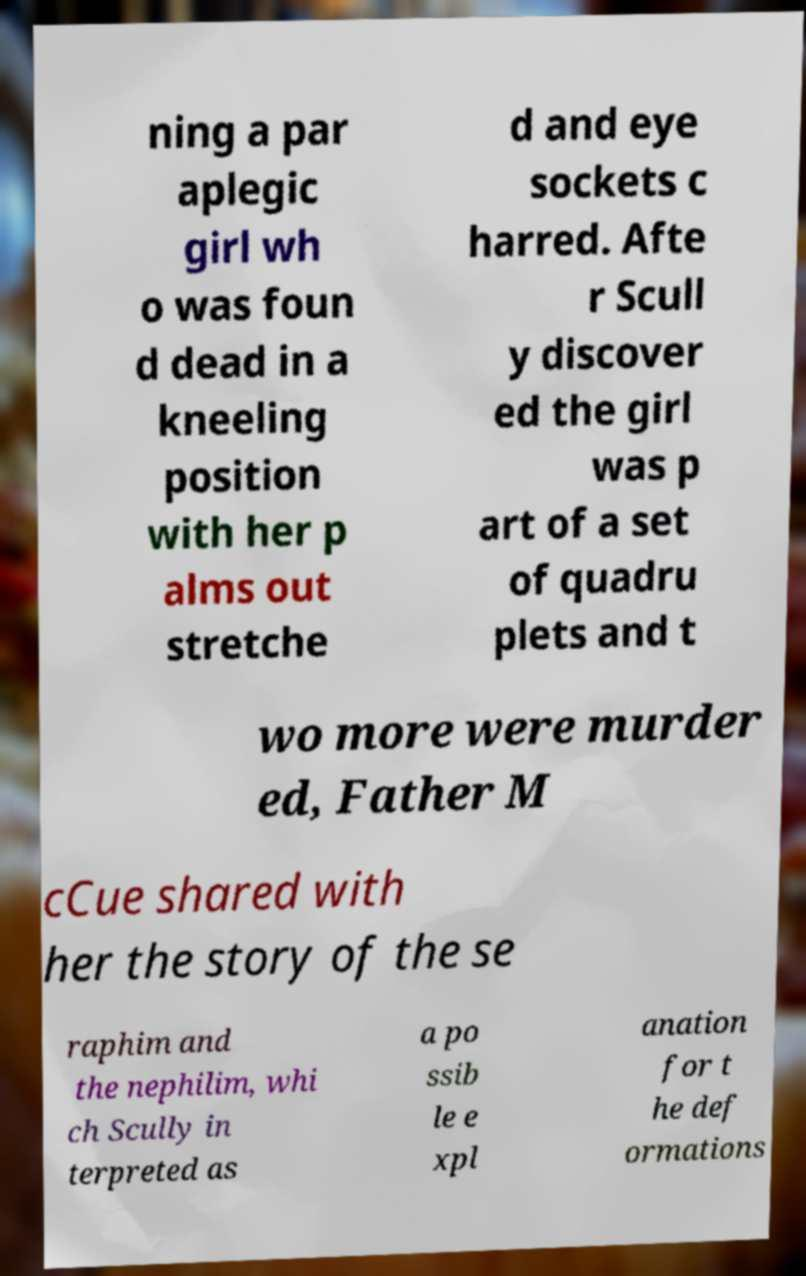Please read and relay the text visible in this image. What does it say? ning a par aplegic girl wh o was foun d dead in a kneeling position with her p alms out stretche d and eye sockets c harred. Afte r Scull y discover ed the girl was p art of a set of quadru plets and t wo more were murder ed, Father M cCue shared with her the story of the se raphim and the nephilim, whi ch Scully in terpreted as a po ssib le e xpl anation for t he def ormations 